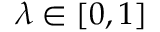<formula> <loc_0><loc_0><loc_500><loc_500>\lambda \in [ 0 , 1 ]</formula> 